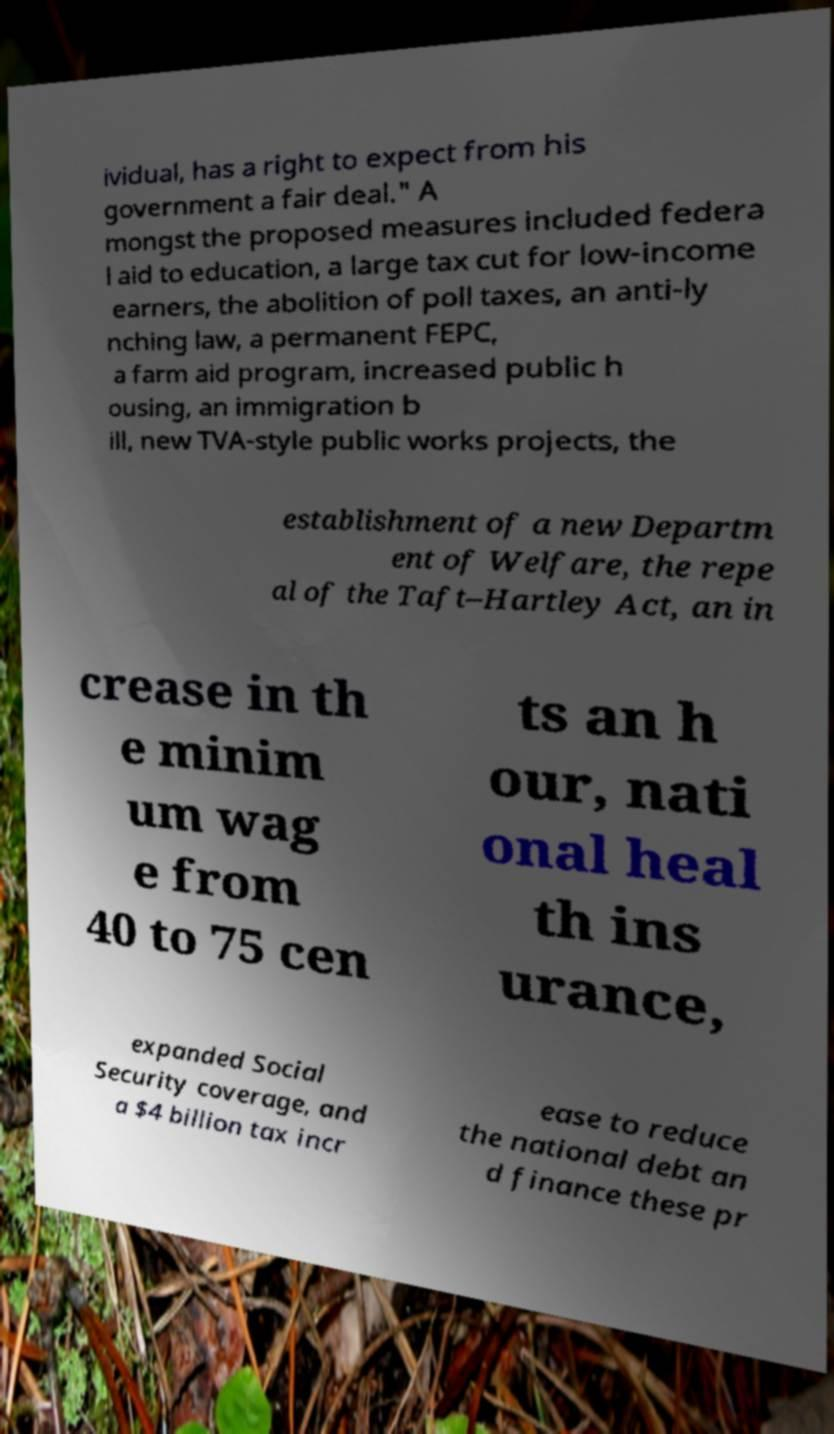Can you read and provide the text displayed in the image?This photo seems to have some interesting text. Can you extract and type it out for me? ividual, has a right to expect from his government a fair deal." A mongst the proposed measures included federa l aid to education, a large tax cut for low-income earners, the abolition of poll taxes, an anti-ly nching law, a permanent FEPC, a farm aid program, increased public h ousing, an immigration b ill, new TVA-style public works projects, the establishment of a new Departm ent of Welfare, the repe al of the Taft–Hartley Act, an in crease in th e minim um wag e from 40 to 75 cen ts an h our, nati onal heal th ins urance, expanded Social Security coverage, and a $4 billion tax incr ease to reduce the national debt an d finance these pr 